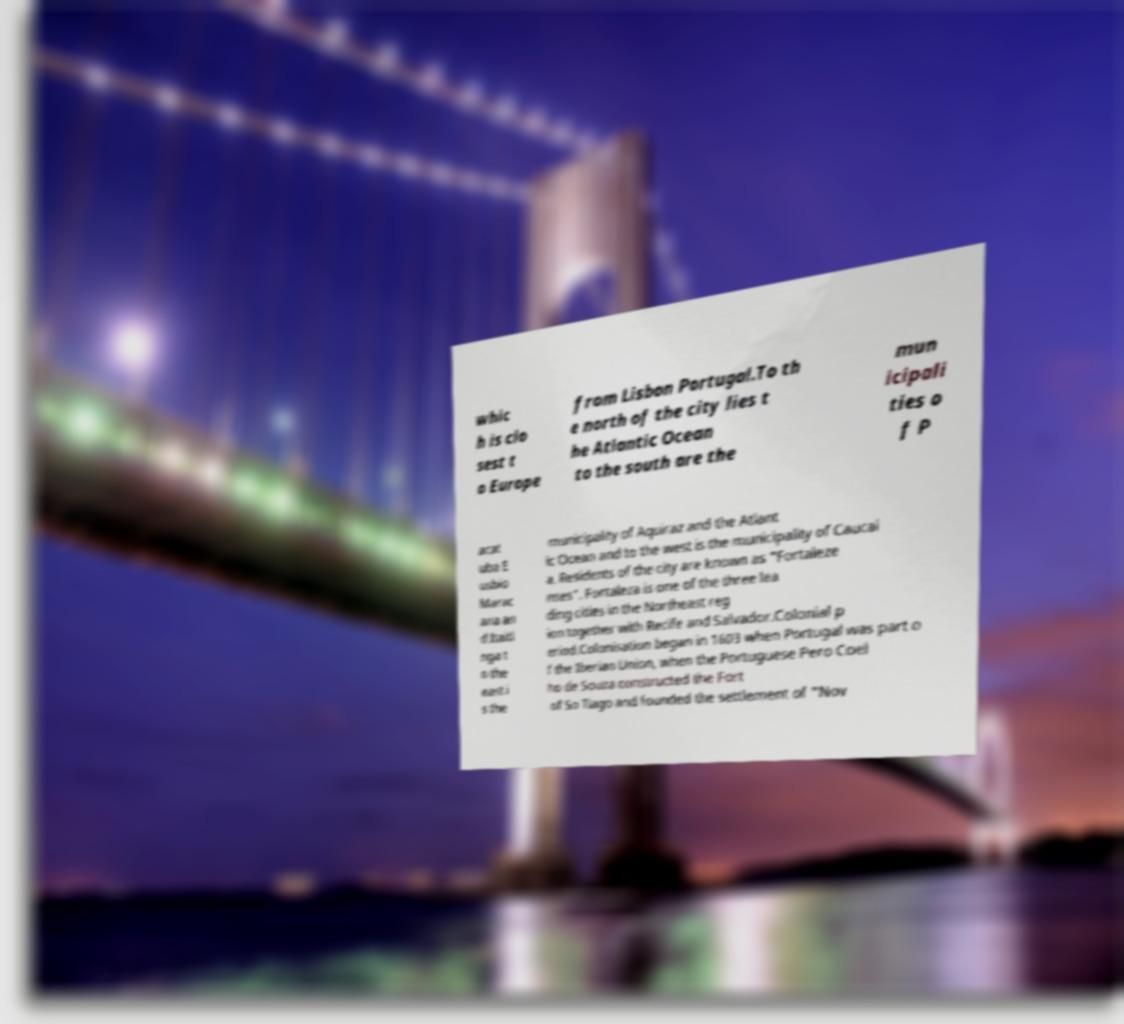I need the written content from this picture converted into text. Can you do that? whic h is clo sest t o Europe from Lisbon Portugal.To th e north of the city lies t he Atlantic Ocean to the south are the mun icipali ties o f P acat uba E usbio Marac ana an d Itaiti nga t o the east i s the municipality of Aquiraz and the Atlant ic Ocean and to the west is the municipality of Caucai a. Residents of the city are known as "Fortaleze nses". Fortaleza is one of the three lea ding cities in the Northeast reg ion together with Recife and Salvador.Colonial p eriod.Colonisation began in 1603 when Portugal was part o f the Iberian Union, when the Portuguese Pero Coel ho de Souza constructed the Fort of So Tiago and founded the settlement of "Nov 